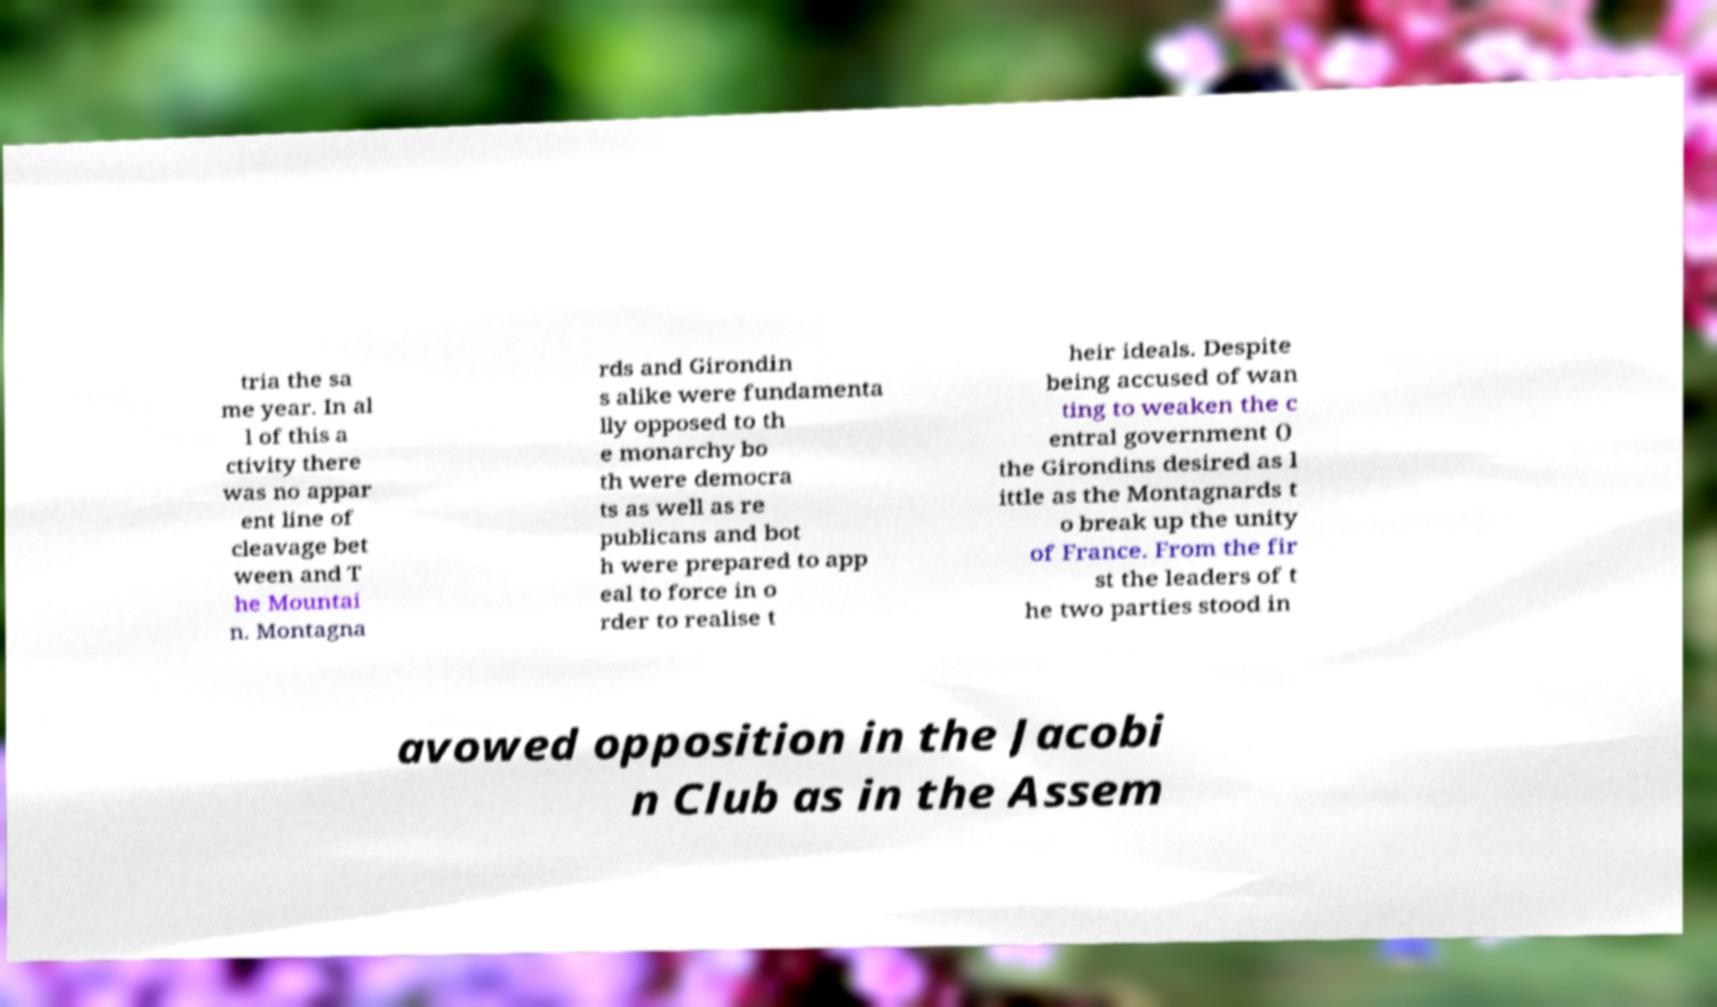What messages or text are displayed in this image? I need them in a readable, typed format. tria the sa me year. In al l of this a ctivity there was no appar ent line of cleavage bet ween and T he Mountai n. Montagna rds and Girondin s alike were fundamenta lly opposed to th e monarchy bo th were democra ts as well as re publicans and bot h were prepared to app eal to force in o rder to realise t heir ideals. Despite being accused of wan ting to weaken the c entral government () the Girondins desired as l ittle as the Montagnards t o break up the unity of France. From the fir st the leaders of t he two parties stood in avowed opposition in the Jacobi n Club as in the Assem 